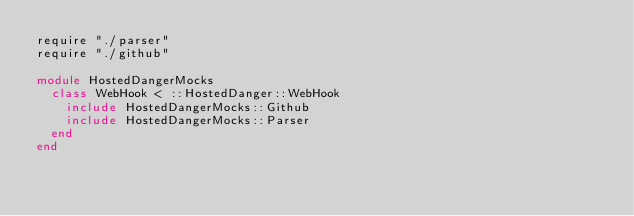<code> <loc_0><loc_0><loc_500><loc_500><_Crystal_>require "./parser"
require "./github"

module HostedDangerMocks
  class WebHook < ::HostedDanger::WebHook
    include HostedDangerMocks::Github
    include HostedDangerMocks::Parser
  end
end
</code> 